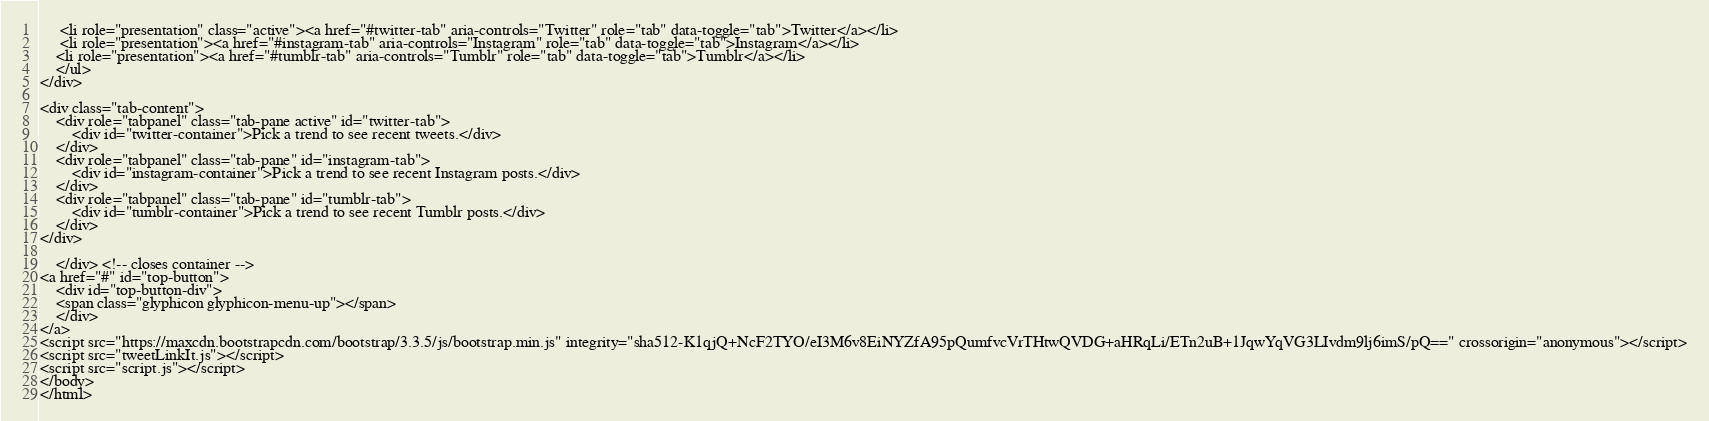<code> <loc_0><loc_0><loc_500><loc_500><_PHP_>	 <li role="presentation" class="active"><a href="#twitter-tab" aria-controls="Twitter" role="tab" data-toggle="tab">Twitter</a></li>
	 <li role="presentation"><a href="#instagram-tab" aria-controls="Instagram" role="tab" data-toggle="tab">Instagram</a></li>
	<li role="presentation"><a href="#tumblr-tab" aria-controls="Tumblr" role="tab" data-toggle="tab">Tumblr</a></li>
    </ul>
</div>

<div class="tab-content">
    <div role="tabpanel" class="tab-pane active" id="twitter-tab">
	    <div id="twitter-container">Pick a trend to see recent tweets.</div>
    </div>
    <div role="tabpanel" class="tab-pane" id="instagram-tab">
	    <div id="instagram-container">Pick a trend to see recent Instagram posts.</div>
    </div>
    <div role="tabpanel" class="tab-pane" id="tumblr-tab">
	    <div id="tumblr-container">Pick a trend to see recent Tumblr posts.</div>
    </div>
</div>
	    
    </div> <!-- closes container -->
<a href="#" id="top-button">
    <div id="top-button-div">
	<span class="glyphicon glyphicon-menu-up"></span>
    </div>
</a>
<script src="https://maxcdn.bootstrapcdn.com/bootstrap/3.3.5/js/bootstrap.min.js" integrity="sha512-K1qjQ+NcF2TYO/eI3M6v8EiNYZfA95pQumfvcVrTHtwQVDG+aHRqLi/ETn2uB+1JqwYqVG3LIvdm9lj6imS/pQ==" crossorigin="anonymous"></script>
<script src="tweetLinkIt.js"></script>
<script src="script.js"></script>
</body>
</html></code> 